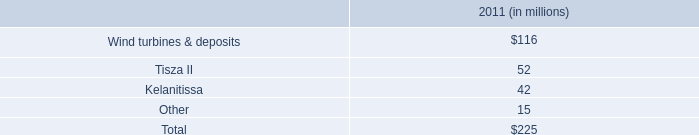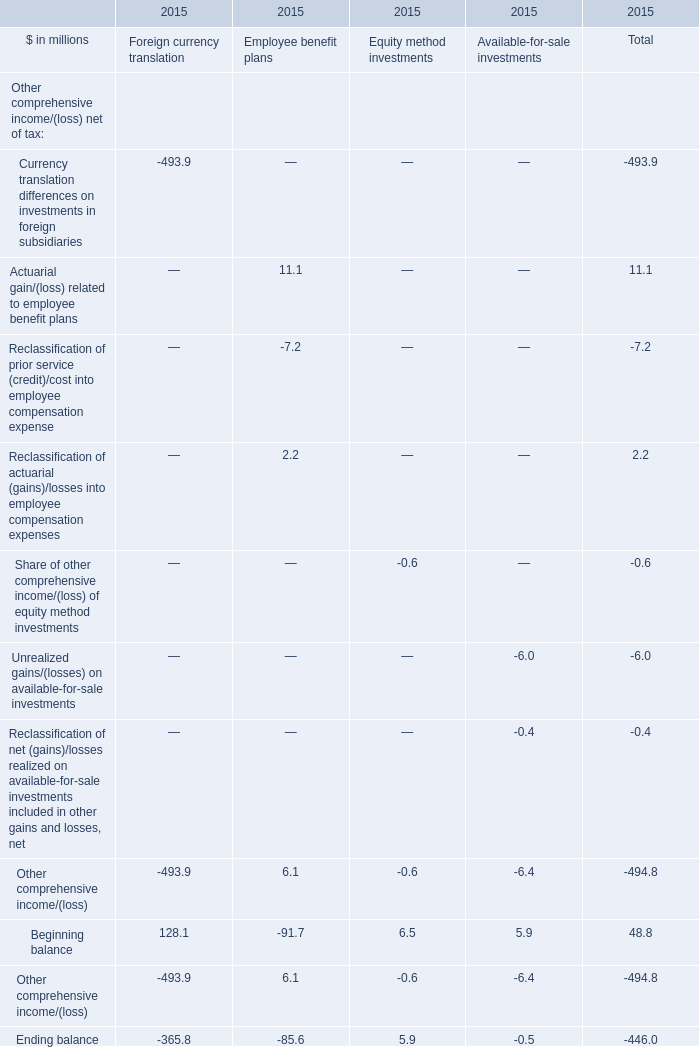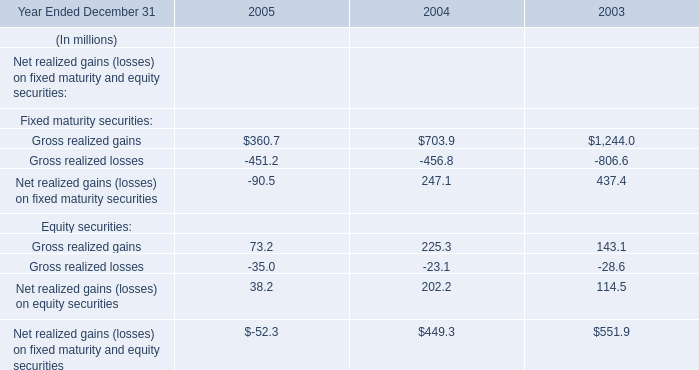during 2011 , what percent of the tisza ii asset group was written off? 
Computations: (52 / 94)
Answer: 0.55319. What is the percentage of all Employee benefit plans that are positive to Total, in 2015 
Computations: (((11.1 + 2.2) + 6.1) / 494.8)
Answer: 0.03921. 